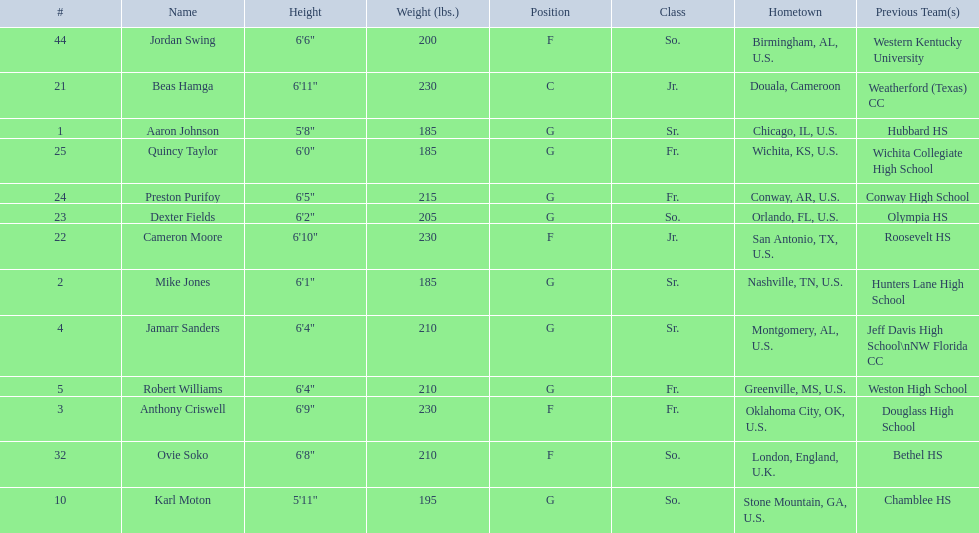Who are all the players? Aaron Johnson, Anthony Criswell, Jamarr Sanders, Robert Williams, Karl Moton, Beas Hamga, Cameron Moore, Dexter Fields, Preston Purifoy, Ovie Soko, Mike Jones, Quincy Taylor, Jordan Swing. Of these, which are not soko? Aaron Johnson, Anthony Criswell, Jamarr Sanders, Robert Williams, Karl Moton, Beas Hamga, Cameron Moore, Dexter Fields, Preston Purifoy, Mike Jones, Quincy Taylor, Jordan Swing. Where are these players from? Sr., Fr., Sr., Fr., So., Jr., Jr., So., Fr., Sr., Fr., So. Of these locations, which are not in the u.s.? Jr. Which player is from this location? Beas Hamga. 